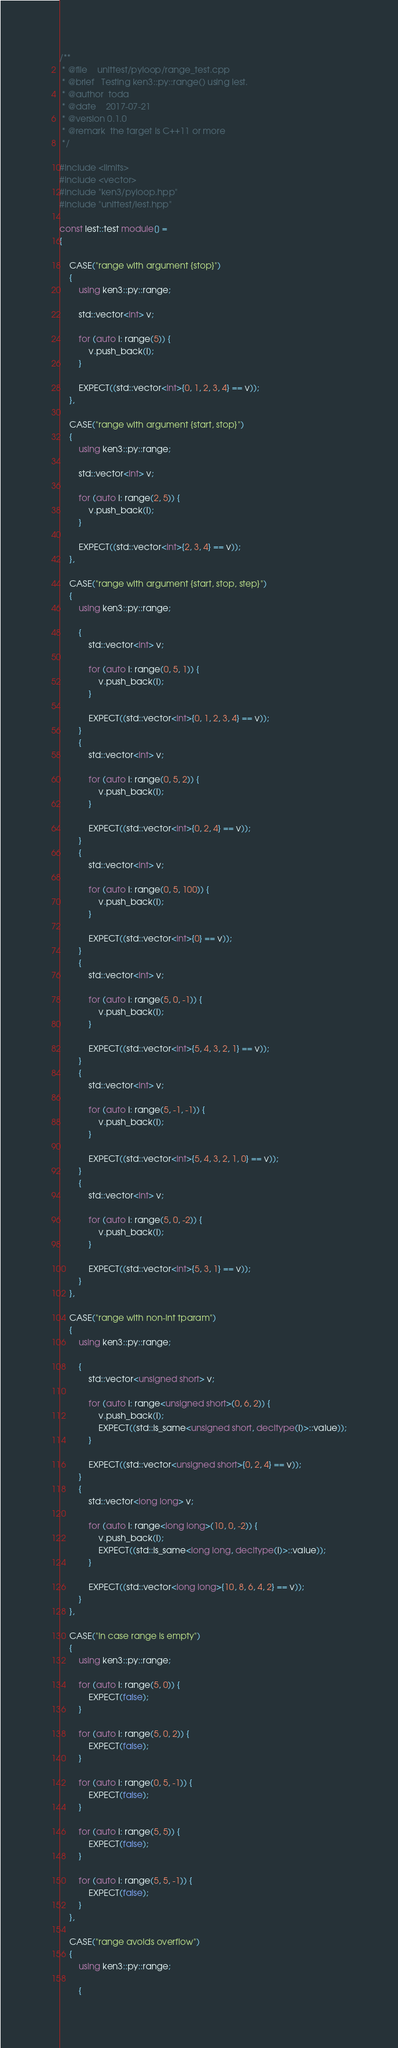Convert code to text. <code><loc_0><loc_0><loc_500><loc_500><_C++_>/**
 * @file    unittest/pyloop/range_test.cpp
 * @brief   Testing ken3::py::range() using lest.
 * @author  toda
 * @date    2017-07-21
 * @version 0.1.0
 * @remark  the target is C++11 or more
 */

#include <limits>
#include <vector>
#include "ken3/pyloop.hpp"
#include "unittest/lest.hpp"

const lest::test module[] =
{

    CASE("range with argument {stop}")
    {
        using ken3::py::range;

        std::vector<int> v;

        for (auto i: range(5)) {
            v.push_back(i);
        }

        EXPECT((std::vector<int>{0, 1, 2, 3, 4} == v));
    },

    CASE("range with argument {start, stop}")
    {
        using ken3::py::range;

        std::vector<int> v;

        for (auto i: range(2, 5)) {
            v.push_back(i);
        }

        EXPECT((std::vector<int>{2, 3, 4} == v));
    },

    CASE("range with argument {start, stop, step}")
    {
        using ken3::py::range;

        {
            std::vector<int> v;

            for (auto i: range(0, 5, 1)) {
                v.push_back(i);
            }

            EXPECT((std::vector<int>{0, 1, 2, 3, 4} == v));
        }
        {
            std::vector<int> v;

            for (auto i: range(0, 5, 2)) {
                v.push_back(i);
            }

            EXPECT((std::vector<int>{0, 2, 4} == v));
        }
        {
            std::vector<int> v;

            for (auto i: range(0, 5, 100)) {
                v.push_back(i);
            }

            EXPECT((std::vector<int>{0} == v));
        }
        {
            std::vector<int> v;

            for (auto i: range(5, 0, -1)) {
                v.push_back(i);
            }

            EXPECT((std::vector<int>{5, 4, 3, 2, 1} == v));
        }
        {
            std::vector<int> v;

            for (auto i: range(5, -1, -1)) {
                v.push_back(i);
            }

            EXPECT((std::vector<int>{5, 4, 3, 2, 1, 0} == v));
        }
        {
            std::vector<int> v;

            for (auto i: range(5, 0, -2)) {
                v.push_back(i);
            }

            EXPECT((std::vector<int>{5, 3, 1} == v));
        }
    },

    CASE("range with non-int tparam")
    {
        using ken3::py::range;

        {
            std::vector<unsigned short> v;

            for (auto i: range<unsigned short>(0, 6, 2)) {
                v.push_back(i);
                EXPECT((std::is_same<unsigned short, decltype(i)>::value));
            }

            EXPECT((std::vector<unsigned short>{0, 2, 4} == v));
        }
        {
            std::vector<long long> v;

            for (auto i: range<long long>(10, 0, -2)) {
                v.push_back(i);
                EXPECT((std::is_same<long long, decltype(i)>::value));
            }

            EXPECT((std::vector<long long>{10, 8, 6, 4, 2} == v));
        }
    },

    CASE("in case range is empty")
    {
        using ken3::py::range;

        for (auto i: range(5, 0)) {
            EXPECT(false);
        }

        for (auto i: range(5, 0, 2)) {
            EXPECT(false);
        }

        for (auto i: range(0, 5, -1)) {
            EXPECT(false);
        }

        for (auto i: range(5, 5)) {
            EXPECT(false);
        }

        for (auto i: range(5, 5, -1)) {
            EXPECT(false);
        }
    },

    CASE("range avoids overflow")
    {
        using ken3::py::range;

        {</code> 